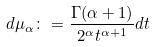Convert formula to latex. <formula><loc_0><loc_0><loc_500><loc_500>d \mu _ { \alpha } \colon = \frac { \Gamma ( \alpha + 1 ) } { 2 ^ { \alpha } t ^ { \alpha + 1 } } d t</formula> 